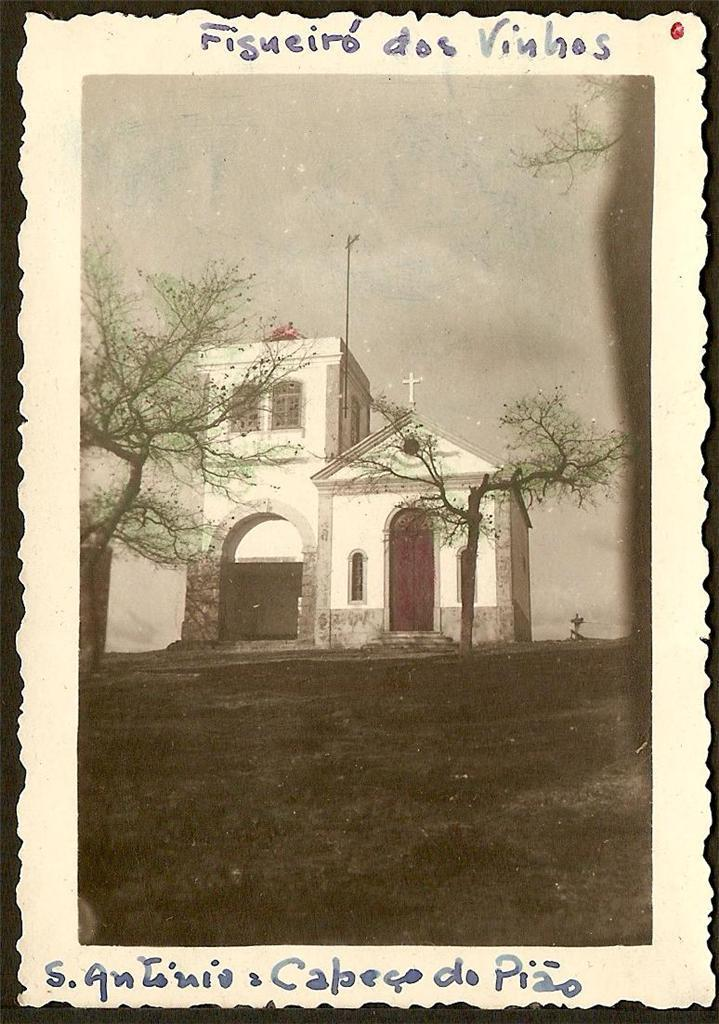Provide a one-sentence caption for the provided image. An old picture of a church called A Antonia Capego do Pizo sits in the background. 